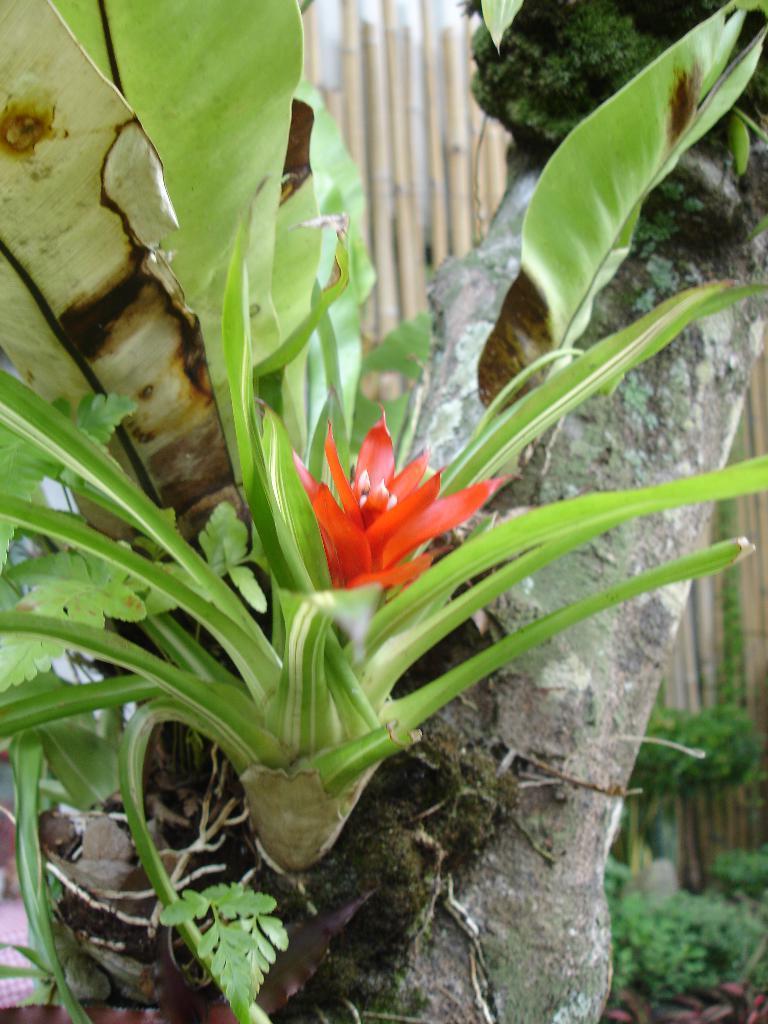Could you give a brief overview of what you see in this image? In this image we can see a red color flower to the tree. The background of the image is slightly blurred, where we can see the fence and few plants here. 